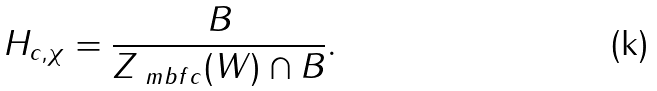Convert formula to latex. <formula><loc_0><loc_0><loc_500><loc_500>H _ { c , \chi } = \frac { B } { Z _ { \ m b f { c } } ( W ) \cap B } .</formula> 